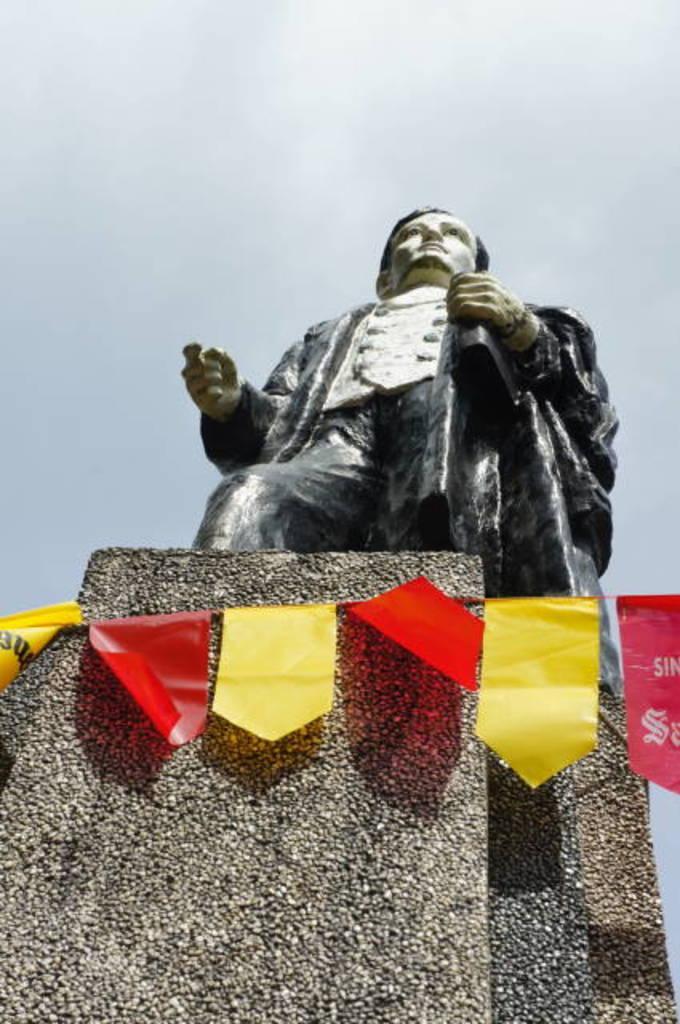Can you describe this image briefly? In this image I can see there is a statue on the rock and there is a decoration and the sky is clear. 